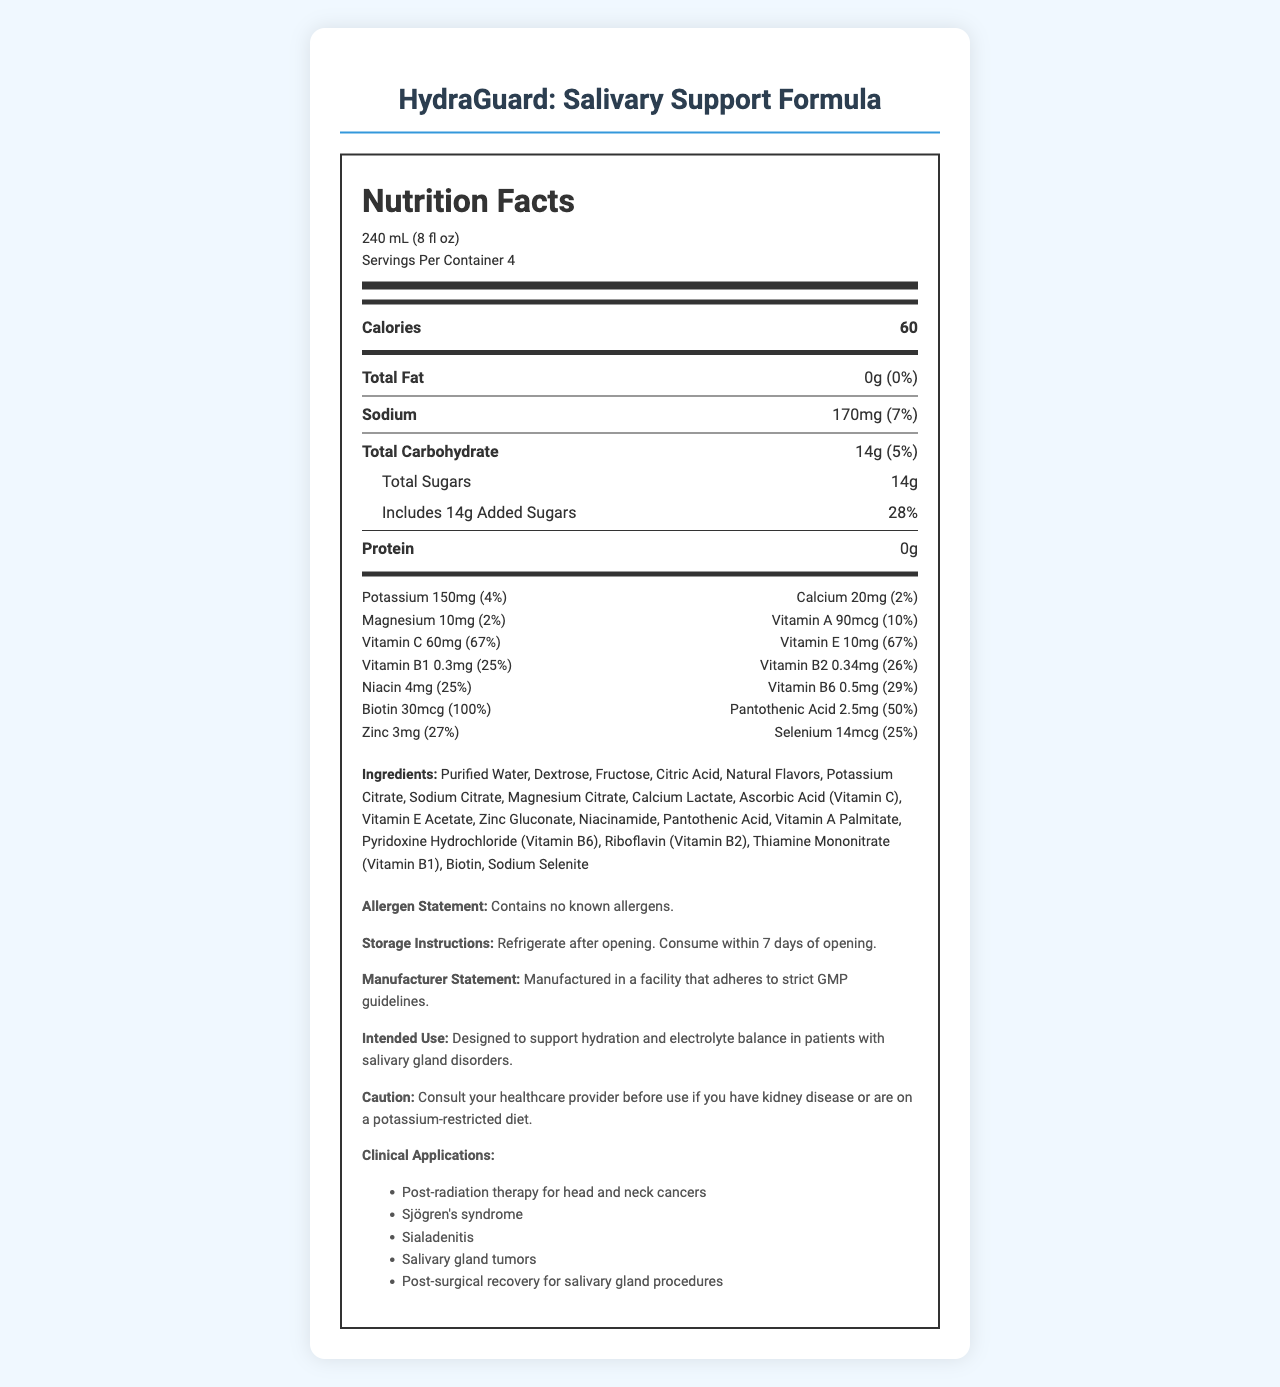what is the serving size of the product? The serving size information is listed at the top under "Nutrition Facts".
Answer: 240 mL (8 fl oz) how many servings are in one container? The number of servings per container is mentioned next to the serving size information.
Answer: 4 how many calories are in one serving? The calorie content is highlighted right after the serving size and servings per container information.
Answer: 60 what is the daily value percentage of sodium per serving? The sodium amount and daily value percentage are listed under the sodium section.
Answer: 7% what is the amount of added sugars in one serving? The total sugars and added sugars amounts are mentioned under the total carbohydrate information.
Answer: 14g which vitamin has the highest daily value percentage? A. Vitamin C B. Biotin C. Vitamin B6 D. Vitamin A Biotin has 100% daily value, which is the highest among the listed vitamins and minerals.
Answer: B. Biotin which of the following minerals has the least daily value percentage? I. Calcium II. Magnesium III. Zinc IV. Selenium Magnesium has a daily value of 2%, which is lower than Calcium (2%), Zinc (27%), and Selenium (25%).
Answer: II. Magnesium Does this product contain any known allergens? The allergen statement clearly states that it contains no known allergens.
Answer: No Can this product be used for post-radiation therapy for head and neck cancers? Post-radiation therapy for head and neck cancers is listed under the clinical applications.
Answer: Yes what is the daily value percentage of vitamin C per serving? The daily value percentage for vitamin C is listed under its amount on the label.
Answer: 67% summarize the main idea of the document. The document is a detailed Nutrition Facts Label for HydraGuard: Salivary Support Formula, including nutritional information, ingredients, storage instructions, intended use, and clinical applications.
Answer: The document provides the nutrition facts for HydraGuard: Salivary Support Formula, a vitamin-fortified electrolyte drink designed to prevent dehydration in patients with salivary gland disorders. It includes detailed information on serving size, servings per container, calories, and the daily values of various nutrients and vitamins. The document also lists ingredients, allergen statements, storage instructions, manufacturer statements, intended use, caution statements, and clinical applications. Are there any storage instructions for this product? The storage instructions state to refrigerate after opening and consume within 7 days of opening.
Answer: Yes what is the recommended use scenario for individuals with kidney disease? The caution statement advises consulting a healthcare provider before use by kidney disease patients or those on potassium-restricted diets.
Answer: Consult your healthcare provider before use if you have kidney disease or are on a potassium-restricted diet. how much protein is present in one serving? The protein amount per serving is listed alongside other nutrients, as 0g.
Answer: 0g what is the total carbohydrate content per serving? A. 12g B. 14g C. 16g D. 18g The total carbohydrate content per serving is listed as 14g.
Answer: B. 14g Is the facility where this product is manufactured GMP compliant? The manufacturer statement mentions that the product is manufactured in a facility adhering to strict GMP guidelines.
Answer: Yes 